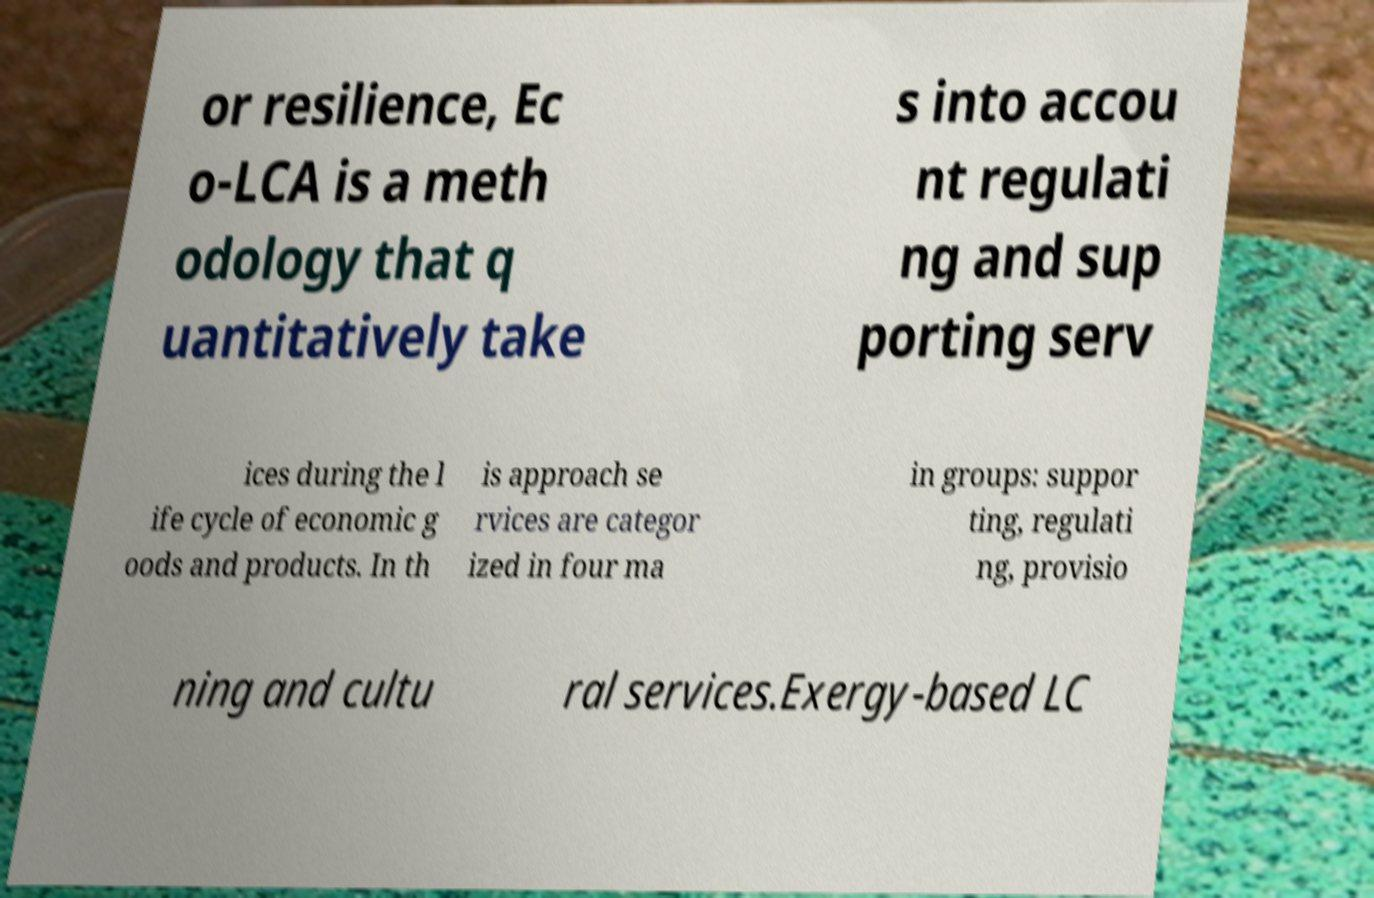Could you extract and type out the text from this image? or resilience, Ec o-LCA is a meth odology that q uantitatively take s into accou nt regulati ng and sup porting serv ices during the l ife cycle of economic g oods and products. In th is approach se rvices are categor ized in four ma in groups: suppor ting, regulati ng, provisio ning and cultu ral services.Exergy-based LC 